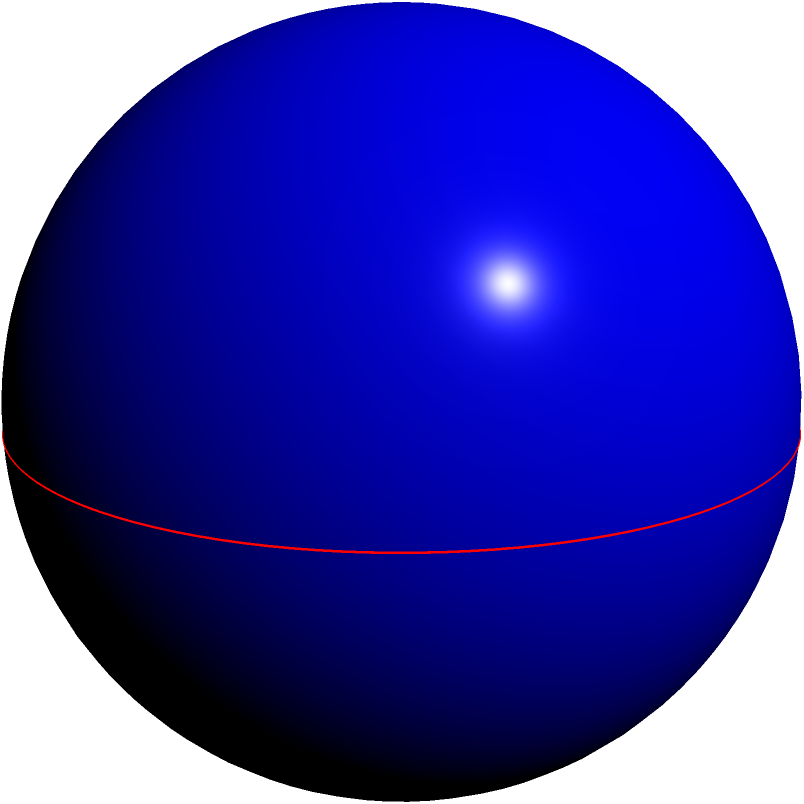In Jean-Louis Bernard's latest sculpture installation, he has created a perfect spherical orb with a diameter of 8 meters. Calculate the surface area of this magnificent sphere, reminiscent of Bernard's signature style in his "Celestial Bodies" series. To calculate the surface area of a sphere given its diameter, we can follow these steps:

1) Recall the formula for the surface area of a sphere:
   $$A = 4\pi r^2$$
   where $A$ is the surface area and $r$ is the radius.

2) We are given the diameter $d = 8$ meters. The radius is half of the diameter:
   $$r = \frac{d}{2} = \frac{8}{2} = 4$$ meters

3) Now, let's substitute this into our formula:
   $$A = 4\pi (4)^2$$

4) Simplify:
   $$A = 4\pi (16) = 64\pi$$ square meters

5) If we want to approximate this value, we can use $\pi \approx 3.14159$:
   $$A \approx 64 (3.14159) \approx 201.06$$ square meters

Thus, the surface area of Jean-Louis Bernard's spherical sculpture is $64\pi$ or approximately 201.06 square meters.
Answer: $64\pi$ square meters 